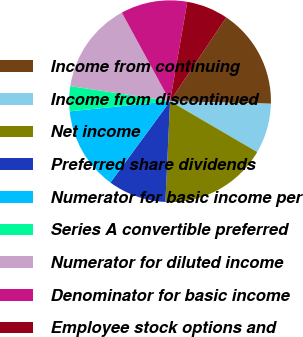Convert chart. <chart><loc_0><loc_0><loc_500><loc_500><pie_chart><fcel>Income from continuing<fcel>Income from discontinued<fcel>Net income<fcel>Preferred share dividends<fcel>Numerator for basic income per<fcel>Series A convertible preferred<fcel>Numerator for diluted income<fcel>Denominator for basic income<fcel>Employee stock options and<nl><fcel>16.0%<fcel>8.0%<fcel>17.33%<fcel>9.33%<fcel>13.33%<fcel>4.0%<fcel>14.67%<fcel>10.67%<fcel>6.67%<nl></chart> 